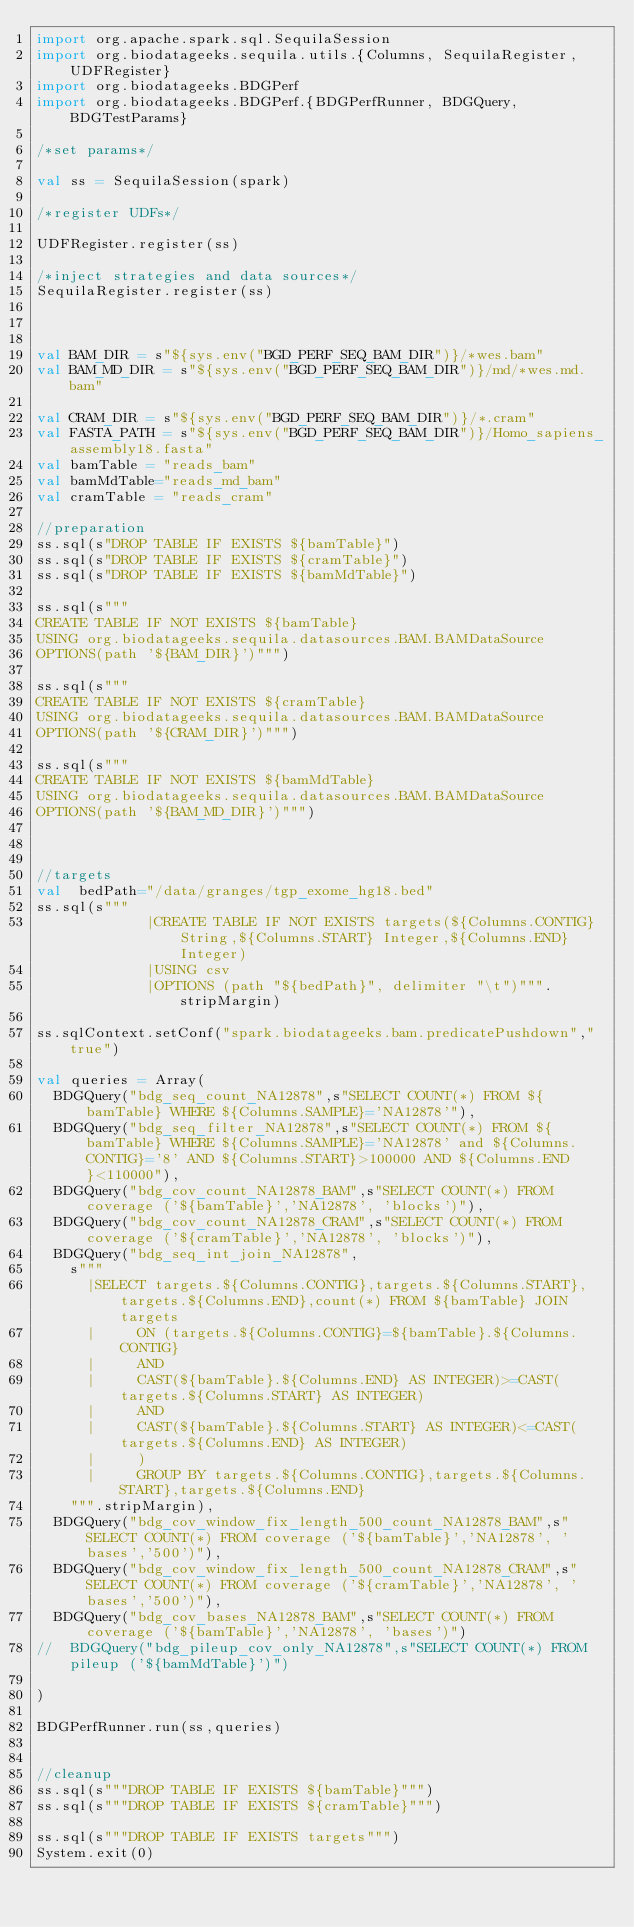<code> <loc_0><loc_0><loc_500><loc_500><_Scala_>import org.apache.spark.sql.SequilaSession
import org.biodatageeks.sequila.utils.{Columns, SequilaRegister, UDFRegister}
import org.biodatageeks.BDGPerf
import org.biodatageeks.BDGPerf.{BDGPerfRunner, BDGQuery, BDGTestParams}

/*set params*/

val ss = SequilaSession(spark)

/*register UDFs*/

UDFRegister.register(ss)

/*inject strategies and data sources*/
SequilaRegister.register(ss)



val BAM_DIR = s"${sys.env("BGD_PERF_SEQ_BAM_DIR")}/*wes.bam"
val BAM_MD_DIR = s"${sys.env("BGD_PERF_SEQ_BAM_DIR")}/md/*wes.md.bam"

val CRAM_DIR = s"${sys.env("BGD_PERF_SEQ_BAM_DIR")}/*.cram"
val FASTA_PATH = s"${sys.env("BGD_PERF_SEQ_BAM_DIR")}/Homo_sapiens_assembly18.fasta"
val bamTable = "reads_bam"
val bamMdTable="reads_md_bam"
val cramTable = "reads_cram"

//preparation
ss.sql(s"DROP TABLE IF EXISTS ${bamTable}")
ss.sql(s"DROP TABLE IF EXISTS ${cramTable}")
ss.sql(s"DROP TABLE IF EXISTS ${bamMdTable}")

ss.sql(s"""
CREATE TABLE IF NOT EXISTS ${bamTable}
USING org.biodatageeks.sequila.datasources.BAM.BAMDataSource
OPTIONS(path '${BAM_DIR}')""")

ss.sql(s"""
CREATE TABLE IF NOT EXISTS ${cramTable}
USING org.biodatageeks.sequila.datasources.BAM.BAMDataSource
OPTIONS(path '${CRAM_DIR}')""")

ss.sql(s"""
CREATE TABLE IF NOT EXISTS ${bamMdTable}
USING org.biodatageeks.sequila.datasources.BAM.BAMDataSource
OPTIONS(path '${BAM_MD_DIR}')""")



//targets
val  bedPath="/data/granges/tgp_exome_hg18.bed"
ss.sql(s"""
             |CREATE TABLE IF NOT EXISTS targets(${Columns.CONTIG} String,${Columns.START} Integer,${Columns.END} Integer)
             |USING csv
             |OPTIONS (path "${bedPath}", delimiter "\t")""".stripMargin)

ss.sqlContext.setConf("spark.biodatageeks.bam.predicatePushdown","true")

val queries = Array(
  BDGQuery("bdg_seq_count_NA12878",s"SELECT COUNT(*) FROM ${bamTable} WHERE ${Columns.SAMPLE}='NA12878'"),
  BDGQuery("bdg_seq_filter_NA12878",s"SELECT COUNT(*) FROM ${bamTable} WHERE ${Columns.SAMPLE}='NA12878' and ${Columns.CONTIG}='8' AND ${Columns.START}>100000 AND ${Columns.END}<110000"),
  BDGQuery("bdg_cov_count_NA12878_BAM",s"SELECT COUNT(*) FROM coverage ('${bamTable}','NA12878', 'blocks')"),
  BDGQuery("bdg_cov_count_NA12878_CRAM",s"SELECT COUNT(*) FROM coverage ('${cramTable}','NA12878', 'blocks')"),
  BDGQuery("bdg_seq_int_join_NA12878",
    s"""
      |SELECT targets.${Columns.CONTIG},targets.${Columns.START},targets.${Columns.END},count(*) FROM ${bamTable} JOIN targets
      |     ON (targets.${Columns.CONTIG}=${bamTable}.${Columns.CONTIG}
      |     AND
      |     CAST(${bamTable}.${Columns.END} AS INTEGER)>=CAST(targets.${Columns.START} AS INTEGER)
      |     AND
      |     CAST(${bamTable}.${Columns.START} AS INTEGER)<=CAST(targets.${Columns.END} AS INTEGER)
      |     )
      |     GROUP BY targets.${Columns.CONTIG},targets.${Columns.START},targets.${Columns.END}
    """.stripMargin),
  BDGQuery("bdg_cov_window_fix_length_500_count_NA12878_BAM",s"SELECT COUNT(*) FROM coverage ('${bamTable}','NA12878', 'bases','500')"),
  BDGQuery("bdg_cov_window_fix_length_500_count_NA12878_CRAM",s"SELECT COUNT(*) FROM coverage ('${cramTable}','NA12878', 'bases','500')"),
  BDGQuery("bdg_cov_bases_NA12878_BAM",s"SELECT COUNT(*) FROM coverage ('${bamTable}','NA12878', 'bases')")
//  BDGQuery("bdg_pileup_cov_only_NA12878",s"SELECT COUNT(*) FROM pileup ('${bamMdTable}')")

)

BDGPerfRunner.run(ss,queries)


//cleanup
ss.sql(s"""DROP TABLE IF EXISTS ${bamTable}""")
ss.sql(s"""DROP TABLE IF EXISTS ${cramTable}""")  

ss.sql(s"""DROP TABLE IF EXISTS targets""")
System.exit(0)


</code> 